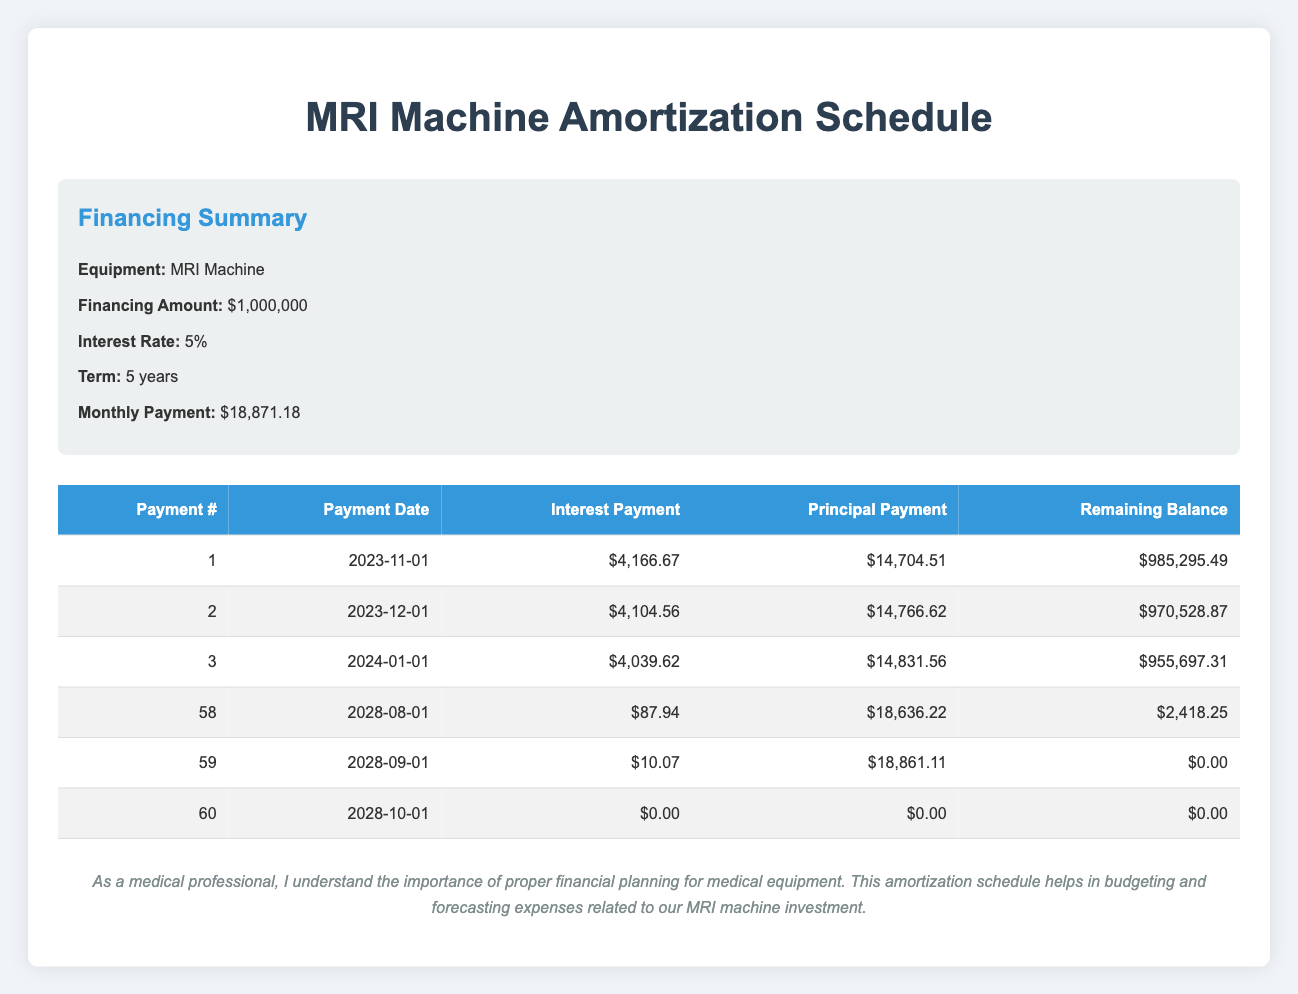What is the total interest payment made in the first month? The first month's interest payment is listed as $4,166.67 in the table.
Answer: $4,166.67 How much is the remaining balance after the 3rd payment? According to the table, after the 3rd payment, the remaining balance is $955,697.31.
Answer: $955,697.31 What is the amount of principal payment made in the 10th payment? The principal payment for the 10th payment is shown as $15,276.17 in the table.
Answer: $15,276.17 How much total principal is paid off by the end of year 1 (after 12 payments)? To find the total principal paid in the first year, we sum the principal payments for the first 12 entries in the table: 14,704.51 + 14,766.62 + 14,831.56 + 14,896.61 + 14,967.85 + 15,030.65 + 15,091.17 + 15,156.54 + 15,210.54 + 15,276.17 + 15,328.32 + 15,381.10 = 178,068.10.
Answer: $178,068.10 Is the interest payment higher in the 5th month compared to the 2nd month? The interest payment for the 5th month is $3,903.33, while for the 2nd month it is $4,104.56. Since $3,903.33 is less than $4,104.56, the statement is false.
Answer: No What is the difference in interest payments between the 1st month and the 12th month? The interest payment for the 1st month is $4,166.67, and for the 12th month it is $3,489.08. Calculating the difference yields: $4,166.67 - $3,489.08 = $677.59.
Answer: $677.59 How much total financing remains after the first year (after 12 payments)? To find the remaining balance after the first year, we take the balance after the 12th payment, which is $820,158.35 as shown in the table.
Answer: $820,158.35 What is the average monthly payment amount throughout the 5-year term? The monthly payment is consistent at $18,871.18. Therefore, the average monthly payment over 60 months remains the same, $18,871.18.
Answer: $18,871.18 How much does the principal payment decrease from the 1st month to the 60th month? The principal payment for the 1st month is $14,704.51, while for the 60th month it is $18,861.11. The decrease in the principal payment is calculated as: $14,704.51 - $18,861.11 = -$4,156.60. This indicates an increase rather than a decrease.
Answer: Increase of $4,156.60 